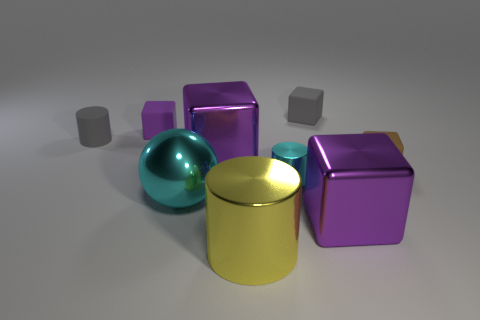Add 1 yellow objects. How many objects exist? 10 Subtract all gray blocks. How many blocks are left? 4 Subtract all tiny cyan cylinders. How many cylinders are left? 2 Subtract all cyan cubes. How many yellow cylinders are left? 1 Add 7 tiny gray rubber things. How many tiny gray rubber things exist? 9 Subtract 0 blue spheres. How many objects are left? 9 Subtract all cylinders. How many objects are left? 6 Subtract 1 balls. How many balls are left? 0 Subtract all yellow balls. Subtract all blue blocks. How many balls are left? 1 Subtract all shiny spheres. Subtract all purple metal objects. How many objects are left? 6 